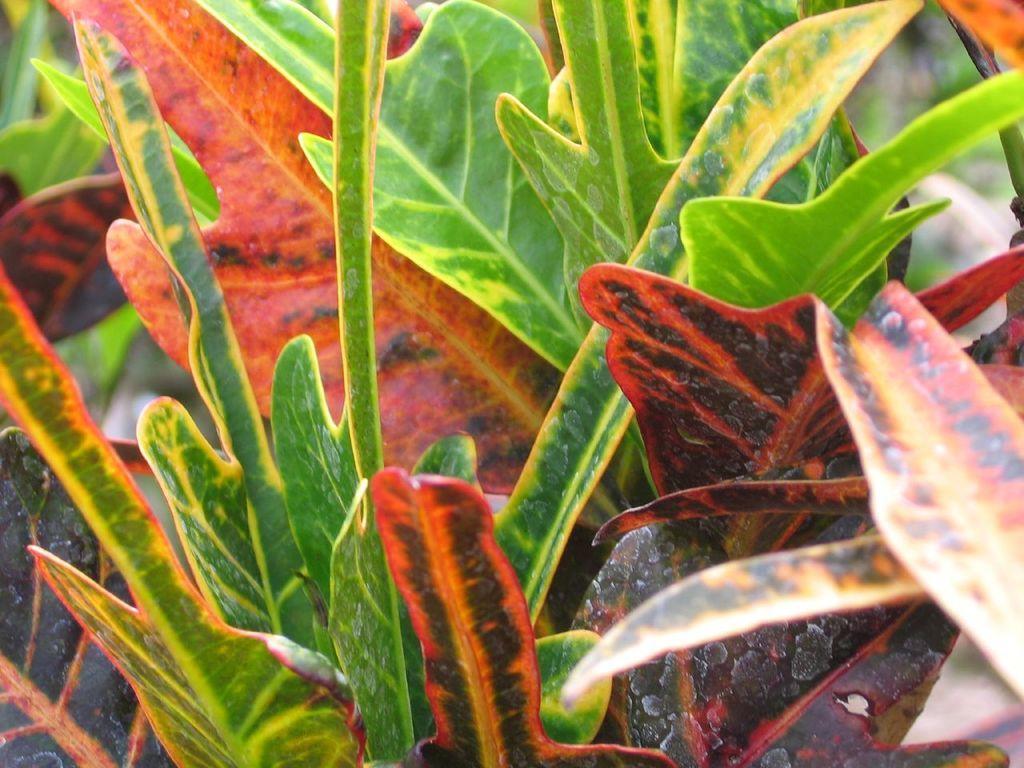Could you give a brief overview of what you see in this image? In this picture there are leaves in the center of the image, which are green and red in the color. 